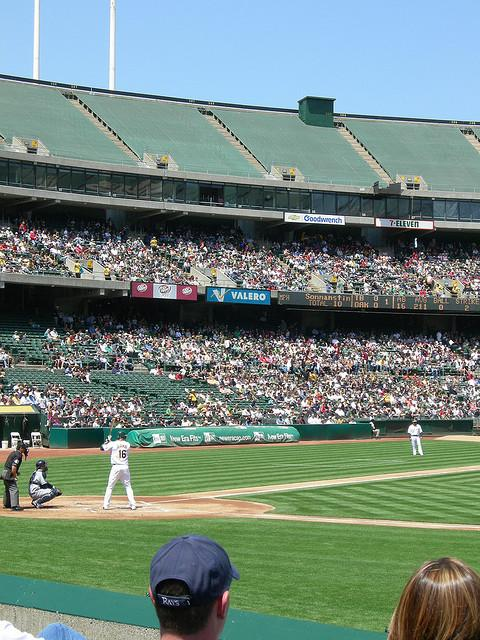The man wearing what color of shirt enforces the rules of the game? Please explain your reasoning. black. An umpire is behind the plate on a baseball diamond. umpires wear dark colored uniforms. 